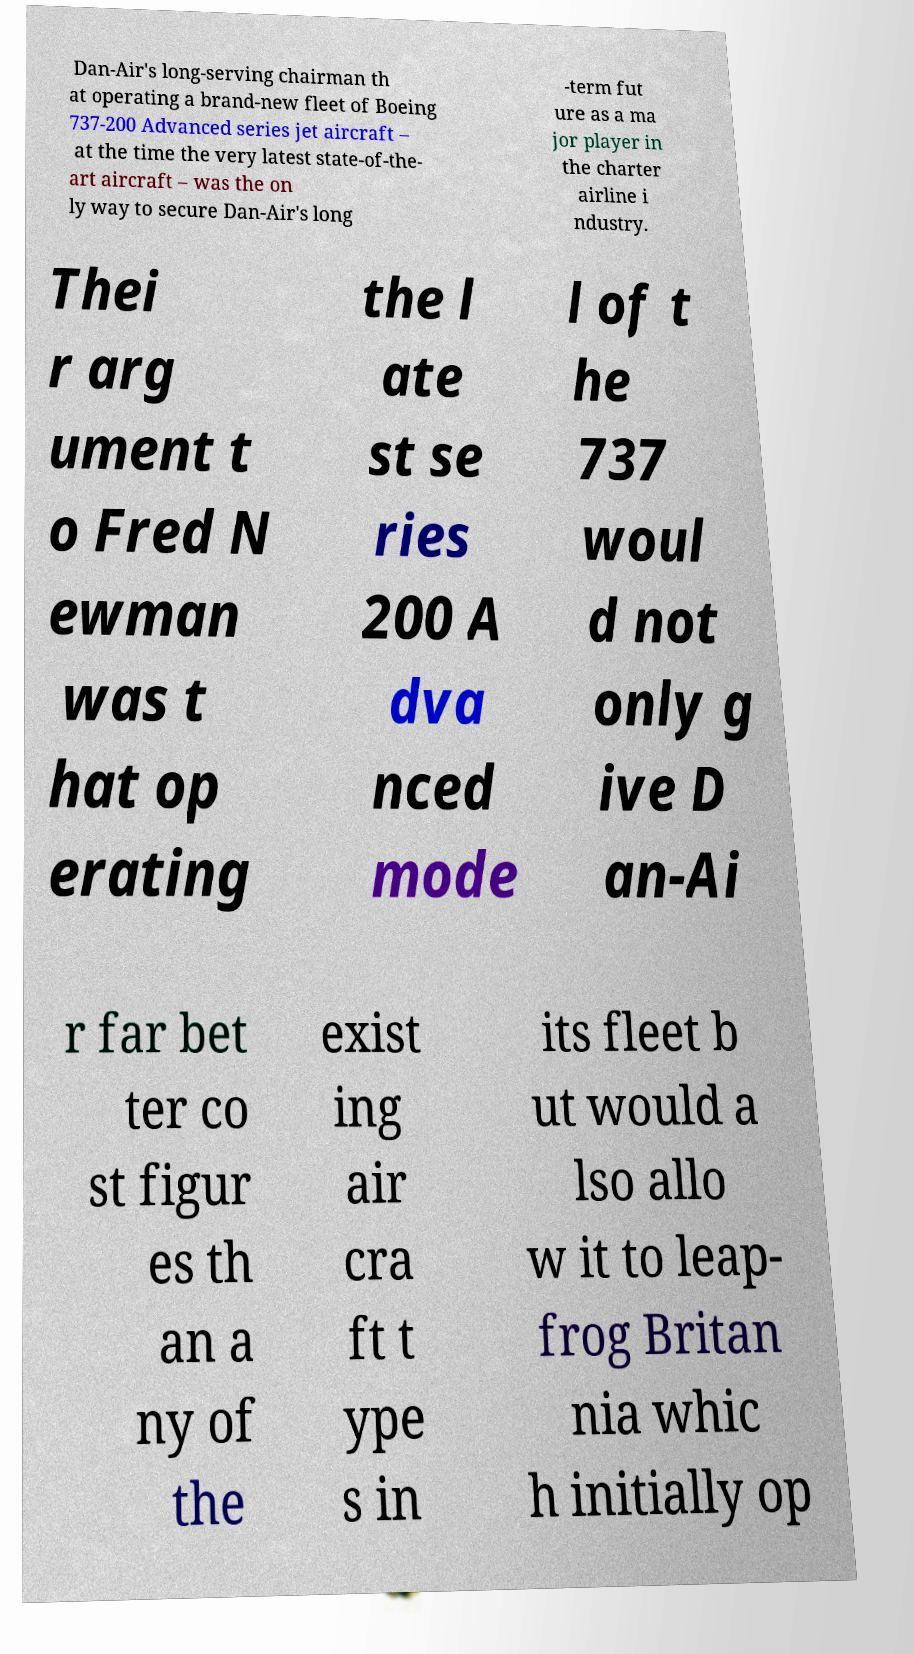What messages or text are displayed in this image? I need them in a readable, typed format. Dan-Air's long-serving chairman th at operating a brand-new fleet of Boeing 737-200 Advanced series jet aircraft – at the time the very latest state-of-the- art aircraft – was the on ly way to secure Dan-Air's long -term fut ure as a ma jor player in the charter airline i ndustry. Thei r arg ument t o Fred N ewman was t hat op erating the l ate st se ries 200 A dva nced mode l of t he 737 woul d not only g ive D an-Ai r far bet ter co st figur es th an a ny of the exist ing air cra ft t ype s in its fleet b ut would a lso allo w it to leap- frog Britan nia whic h initially op 